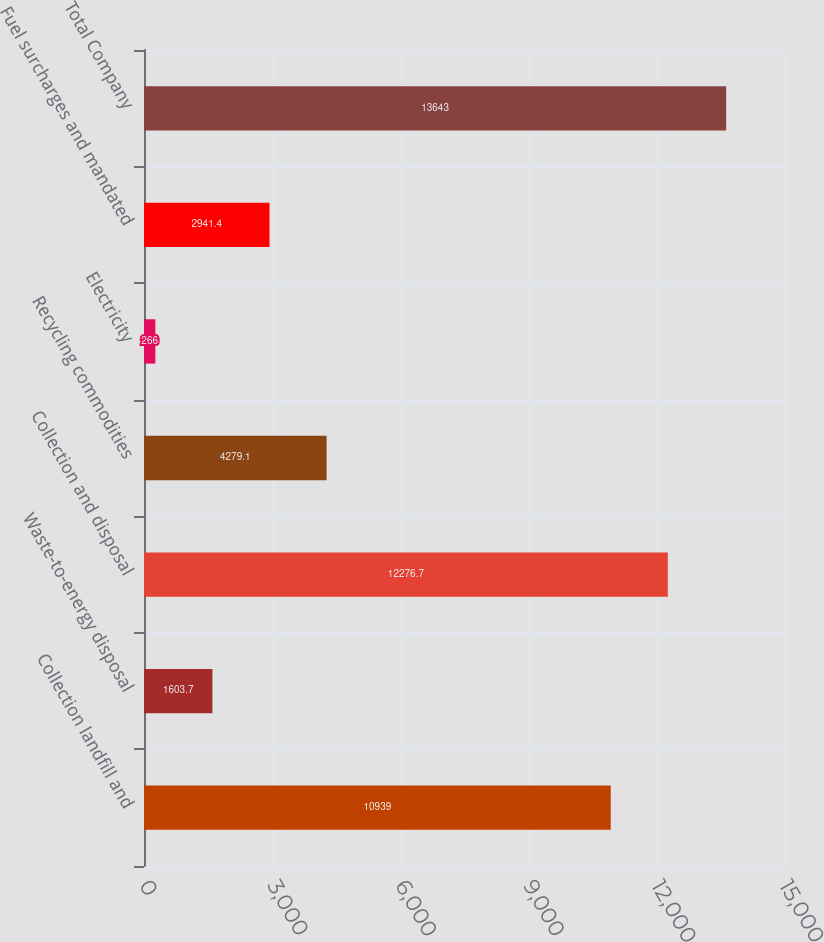Convert chart. <chart><loc_0><loc_0><loc_500><loc_500><bar_chart><fcel>Collection landfill and<fcel>Waste-to-energy disposal<fcel>Collection and disposal<fcel>Recycling commodities<fcel>Electricity<fcel>Fuel surcharges and mandated<fcel>Total Company<nl><fcel>10939<fcel>1603.7<fcel>12276.7<fcel>4279.1<fcel>266<fcel>2941.4<fcel>13643<nl></chart> 